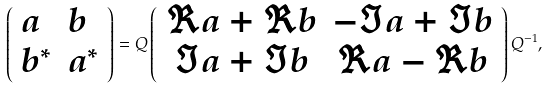Convert formula to latex. <formula><loc_0><loc_0><loc_500><loc_500>\left ( \begin{array} { l l } a & b \\ b ^ { \ast } & a ^ { \ast } \end{array} \right ) = Q \left ( \begin{array} { c c } { \Re } a + { \Re } b & - { \Im } a + { \Im } b \\ { \Im } a + { \Im } b & { \Re } a - { \Re } b \end{array} \right ) Q ^ { - 1 } ,</formula> 